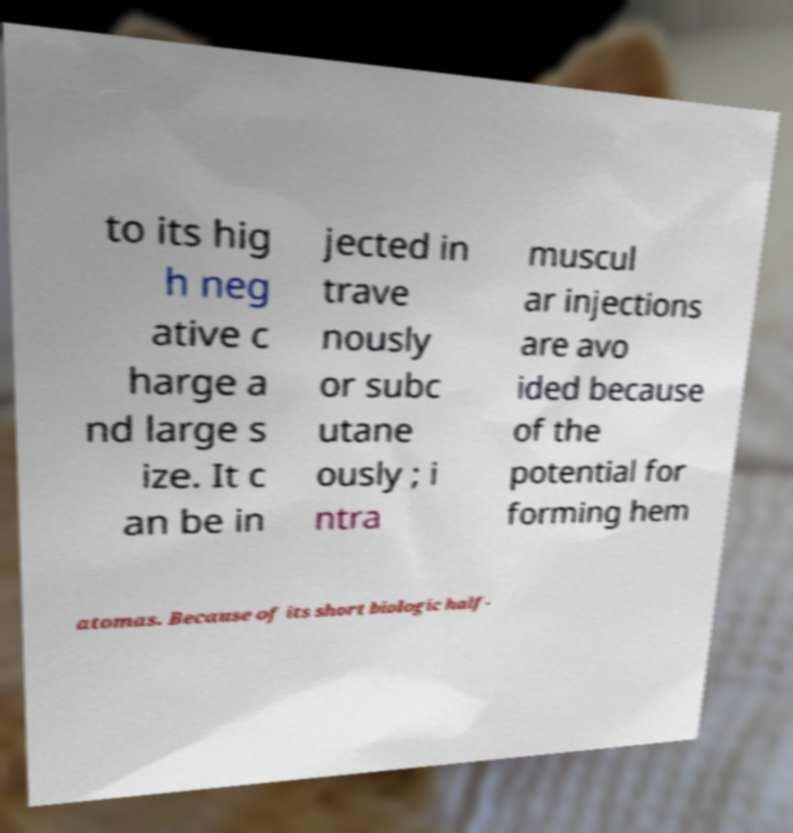There's text embedded in this image that I need extracted. Can you transcribe it verbatim? to its hig h neg ative c harge a nd large s ize. It c an be in jected in trave nously or subc utane ously ; i ntra muscul ar injections are avo ided because of the potential for forming hem atomas. Because of its short biologic half- 